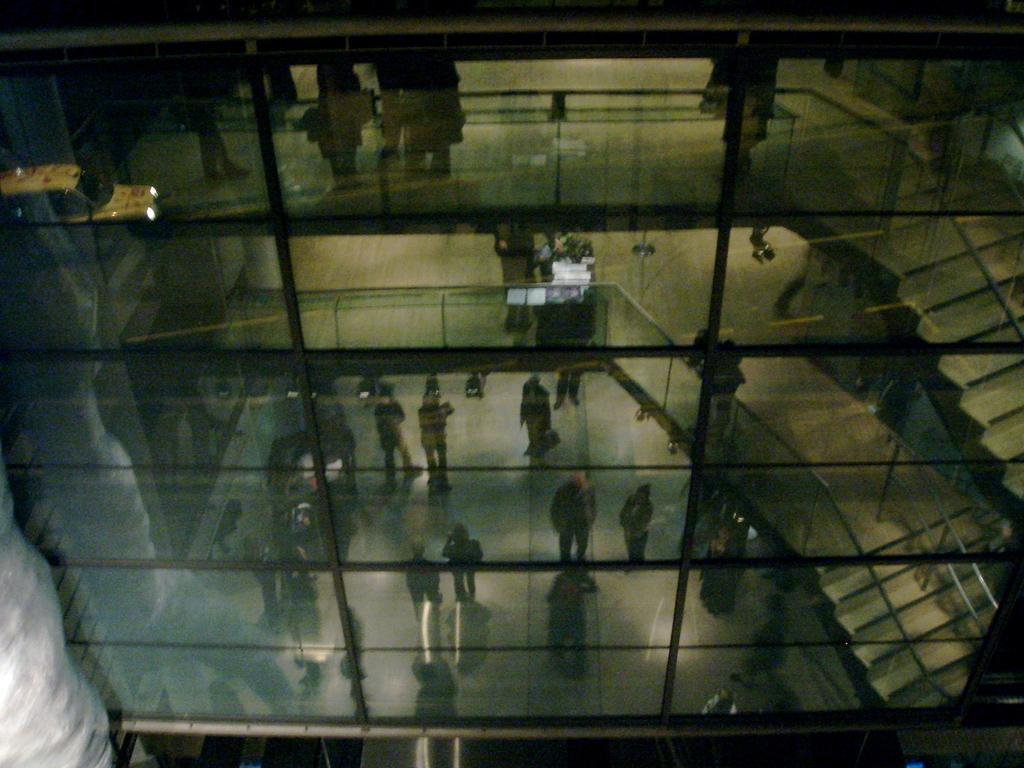In one or two sentences, can you explain what this image depicts? There is a glass building through which we can see people, stairs and fencing. 